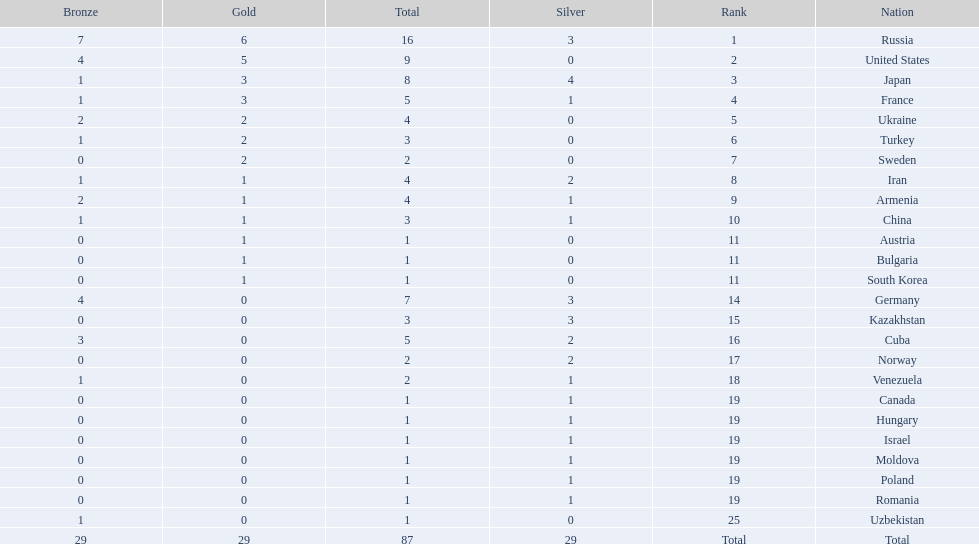How many gold medals did the united states win? 5. Who won more than 5 gold medals? Russia. 